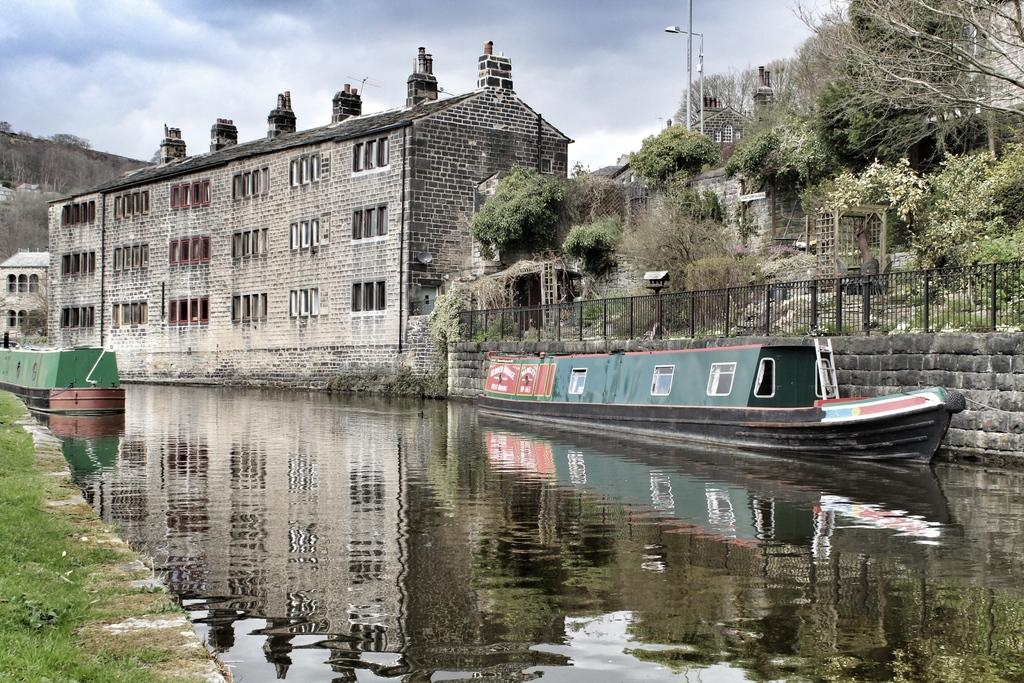What body of water is present in the image? There is a river in the image. What is floating on the river? There is a boat in the river. What type of vegetation can be seen in the image? There are green color trees in the image. What type of structure is visible in the image? There is a building in the image. What is visible in the sky in the image? The sky is visible in the image and it is cloudy. Can you touch the thought that is present in the image? There is no thought present in the image; it is a scene featuring a river, a boat, green trees, a building, and a cloudy sky. 